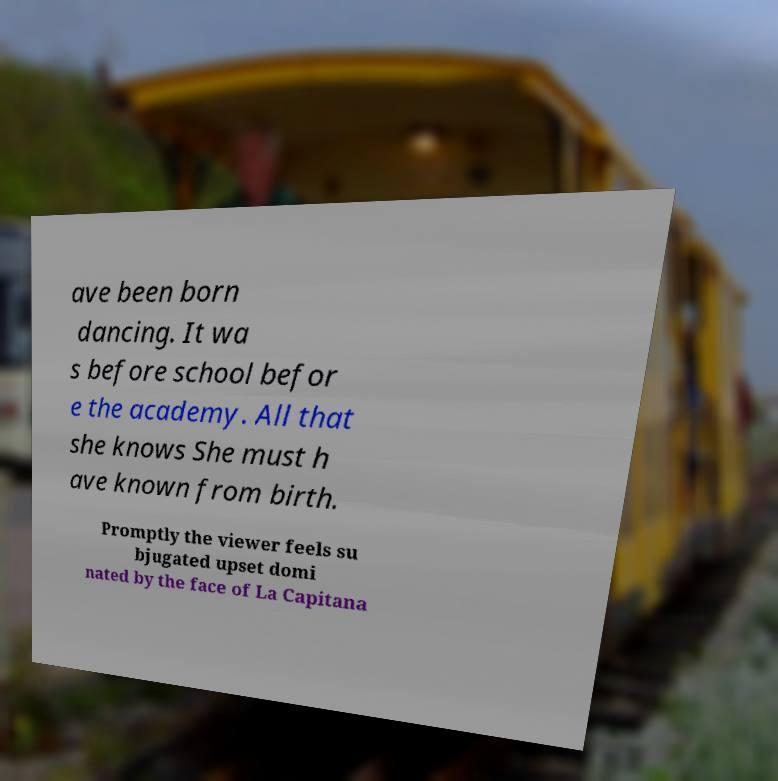Can you read and provide the text displayed in the image?This photo seems to have some interesting text. Can you extract and type it out for me? ave been born dancing. It wa s before school befor e the academy. All that she knows She must h ave known from birth. Promptly the viewer feels su bjugated upset domi nated by the face of La Capitana 